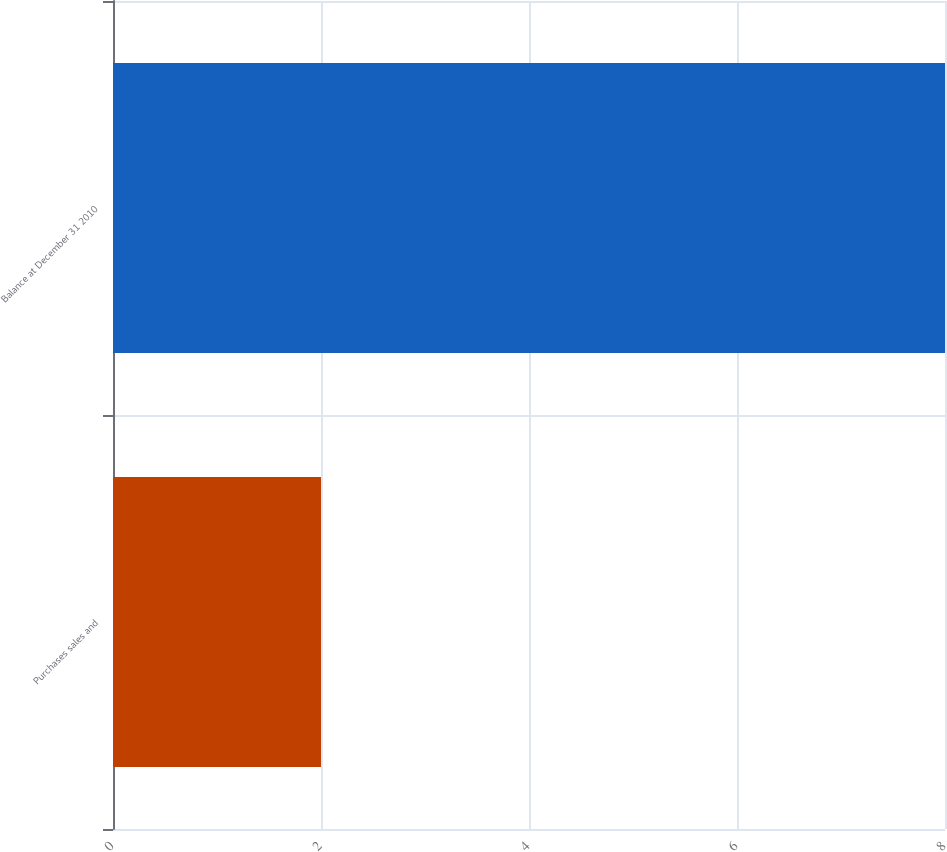<chart> <loc_0><loc_0><loc_500><loc_500><bar_chart><fcel>Purchases sales and<fcel>Balance at December 31 2010<nl><fcel>2<fcel>8<nl></chart> 